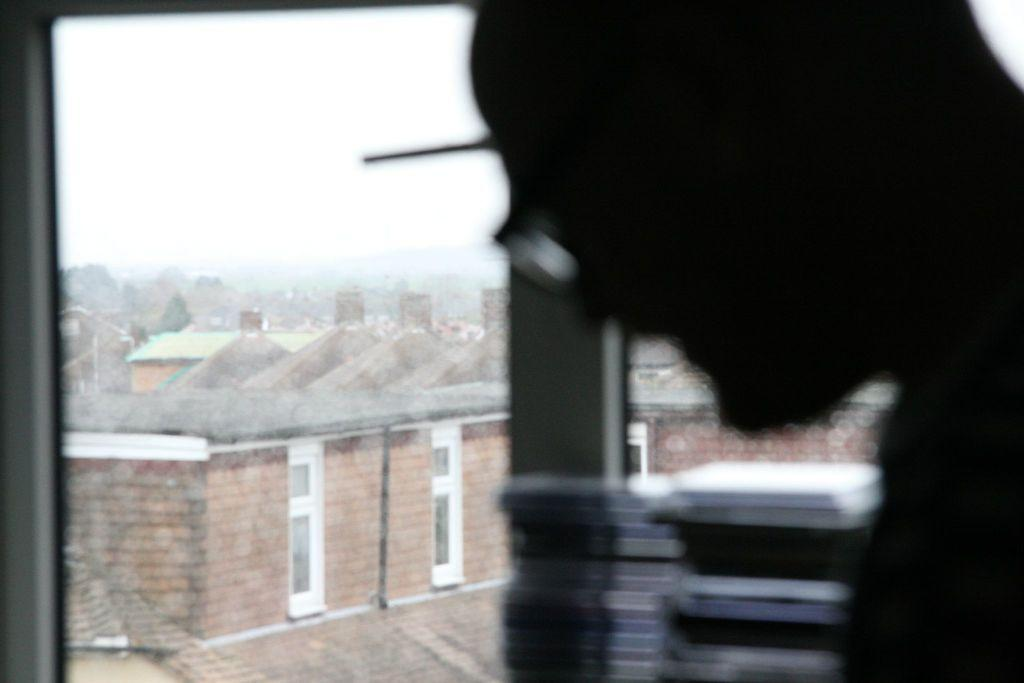Who is on the right side of the image? There is a man on the right side of the image. What is the man standing near in the image? There is a glass window in the image. What can be seen outside the window? Buildings are visible outside the window. What is visible at the top of the image? The sky is visible at the top of the image. What reason does the man have for feeling disgust in the image? There is no indication of any emotion, such as disgust, in the image. The man is simply standing near a window. 